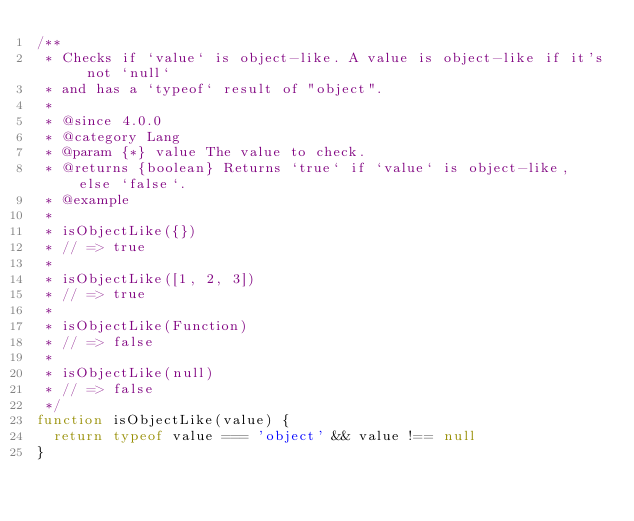Convert code to text. <code><loc_0><loc_0><loc_500><loc_500><_JavaScript_>/**
 * Checks if `value` is object-like. A value is object-like if it's not `null`
 * and has a `typeof` result of "object".
 *
 * @since 4.0.0
 * @category Lang
 * @param {*} value The value to check.
 * @returns {boolean} Returns `true` if `value` is object-like, else `false`.
 * @example
 *
 * isObjectLike({})
 * // => true
 *
 * isObjectLike([1, 2, 3])
 * // => true
 *
 * isObjectLike(Function)
 * // => false
 *
 * isObjectLike(null)
 * // => false
 */
function isObjectLike(value) {
  return typeof value === 'object' && value !== null
}


</code> 